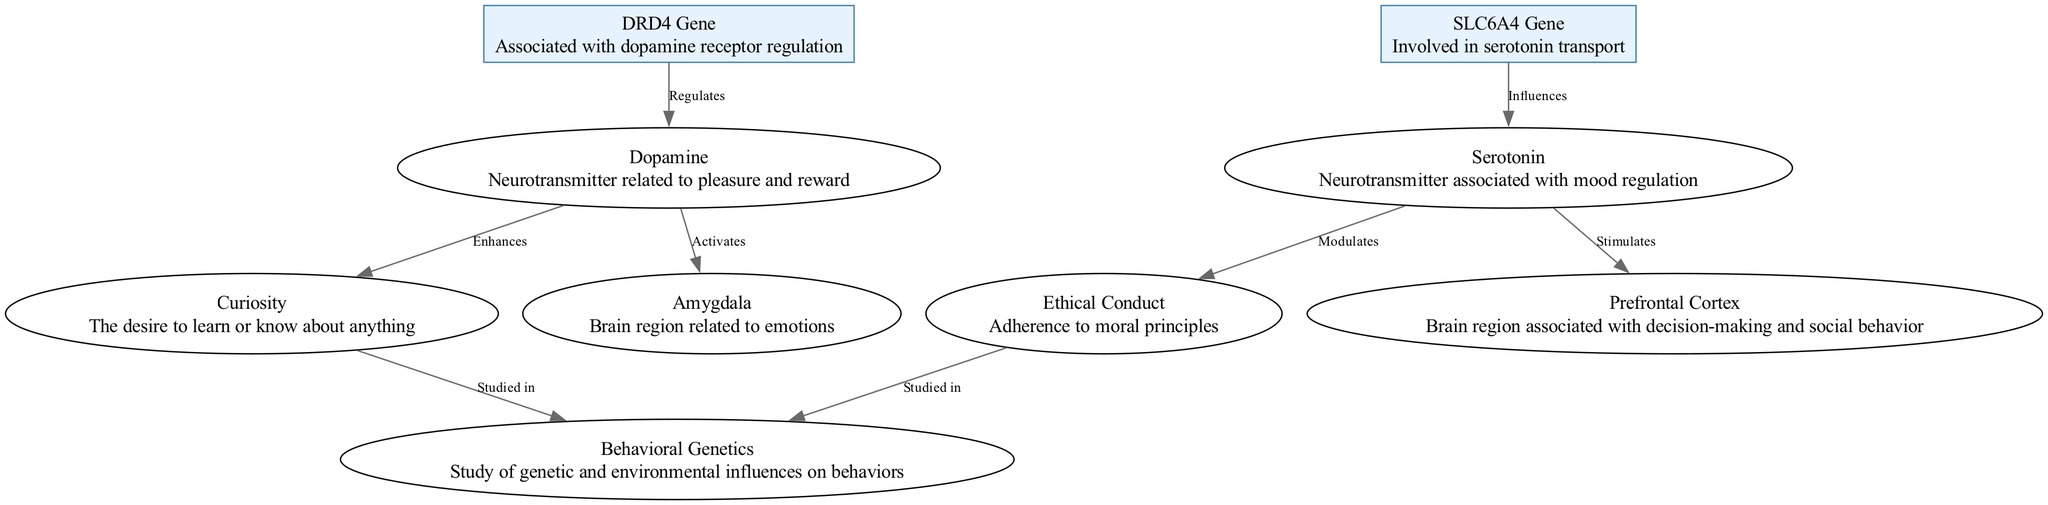What is the first gene listed in the diagram? The first gene listed in the diagram is represented by the node with ID "Gene1", which corresponds to the "DRD4 Gene".
Answer: DRD4 Gene How many traits are mentioned in the diagram? There are two traits represented in the diagram, which are "Curiosity" and "Ethical Conduct". Counting the nodes labeled as traits reveals a total of two.
Answer: 2 Which neurotransmitter is linked to the regulation of the DRD4 gene? The DRD4 gene regulates the neurotransmitter "Dopamine", which is indicated by the edge connecting Gene1 to Neuro1 with the label "Regulates".
Answer: Dopamine What is the role of SLC6A4 gene on serotonin? The SLC6A4 gene is described as "Involved in serotonin transport", indicating its influence on the availability of serotonin in the brain.
Answer: Influences Which brain region is stimulated by serotonin according to the diagram? The diagram shows that serotonin stimulates the "Prefrontal Cortex", indicated by the edge connecting Neuro2 to Neuro4 with the label "Stimulates".
Answer: Prefrontal Cortex What behavioral study involves both traits in the diagram? The diagram refers to "Behavioral Genetics" as the study involving both traits, as indicated by the connections from both traits to the node labeled "Behavioral Genetics".
Answer: Behavioral Genetics How are curiosity and ethical conduct studied together according to the diagram? Both curiosity and ethical conduct are connected to the same interaction node labeled "Behavioral Genetics", which suggests that they are studied together in the context of genetic and environmental influences on behavior.
Answer: Studied in Behavioral Genetics Identify a neurotransmitter that activates the amygdala. The diagram shows that "Dopamine" activates the amygdala, as evidenced by the edge between Neuro1 and Neuro3 with the label "Activates".
Answer: Dopamine What type of diagram is this, and what is its focus? This is a biomedical diagram focusing on the genetic basis of psychological traits linked to curiosity and ethical conduct, as indicated by the specific nodes and relationships presented.
Answer: Biomedical Diagram 